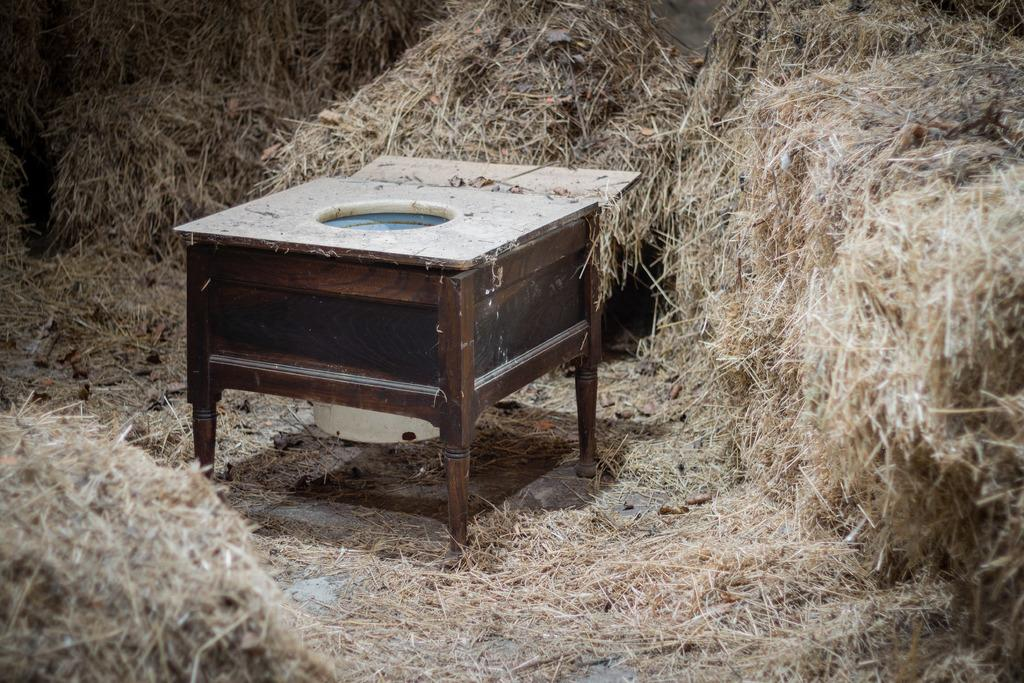What type of table is in the image? There is a wooden table in the image. Where is the wooden table located? The wooden table is in the grass. What can be seen in the background of the image? There is dry grass visible from left to right in the image. What type of cherries are growing on the table in the image? There are no cherries present in the image; the table is in the grass with no fruit visible. 